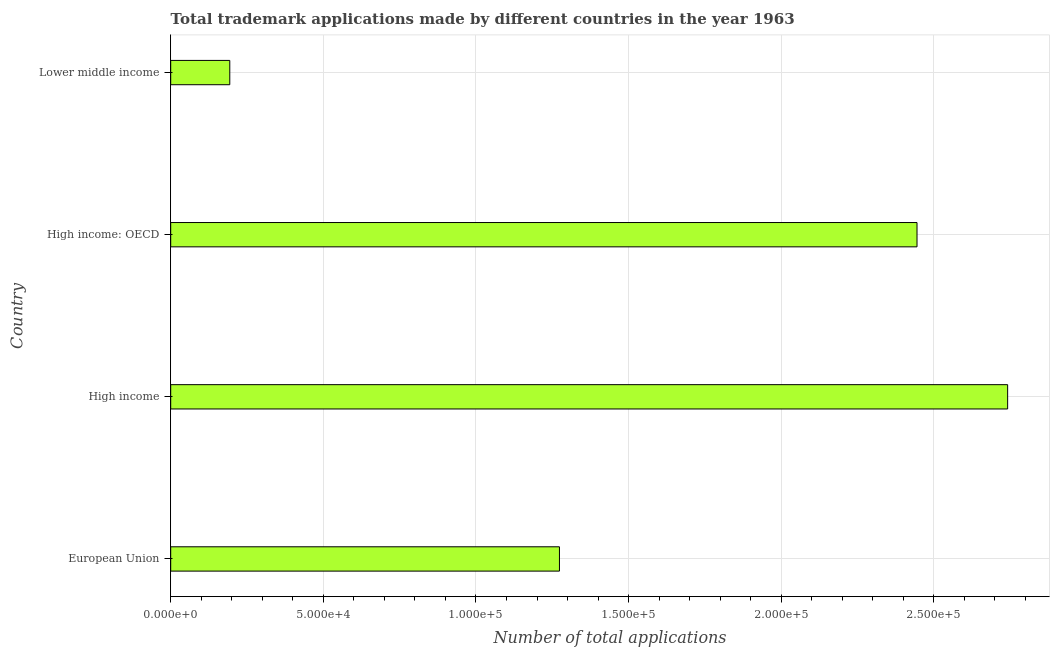Does the graph contain any zero values?
Keep it short and to the point. No. What is the title of the graph?
Provide a short and direct response. Total trademark applications made by different countries in the year 1963. What is the label or title of the X-axis?
Make the answer very short. Number of total applications. What is the label or title of the Y-axis?
Make the answer very short. Country. What is the number of trademark applications in Lower middle income?
Provide a succinct answer. 1.94e+04. Across all countries, what is the maximum number of trademark applications?
Offer a very short reply. 2.74e+05. Across all countries, what is the minimum number of trademark applications?
Give a very brief answer. 1.94e+04. In which country was the number of trademark applications minimum?
Ensure brevity in your answer.  Lower middle income. What is the sum of the number of trademark applications?
Offer a terse response. 6.65e+05. What is the difference between the number of trademark applications in High income and Lower middle income?
Your answer should be very brief. 2.55e+05. What is the average number of trademark applications per country?
Offer a terse response. 1.66e+05. What is the median number of trademark applications?
Your answer should be very brief. 1.86e+05. In how many countries, is the number of trademark applications greater than 180000 ?
Provide a short and direct response. 2. What is the ratio of the number of trademark applications in High income to that in High income: OECD?
Keep it short and to the point. 1.12. What is the difference between the highest and the second highest number of trademark applications?
Provide a succinct answer. 2.97e+04. What is the difference between the highest and the lowest number of trademark applications?
Give a very brief answer. 2.55e+05. How many bars are there?
Offer a very short reply. 4. Are the values on the major ticks of X-axis written in scientific E-notation?
Your answer should be compact. Yes. What is the Number of total applications in European Union?
Provide a succinct answer. 1.27e+05. What is the Number of total applications of High income?
Make the answer very short. 2.74e+05. What is the Number of total applications of High income: OECD?
Your answer should be compact. 2.44e+05. What is the Number of total applications in Lower middle income?
Keep it short and to the point. 1.94e+04. What is the difference between the Number of total applications in European Union and High income?
Provide a succinct answer. -1.47e+05. What is the difference between the Number of total applications in European Union and High income: OECD?
Provide a short and direct response. -1.17e+05. What is the difference between the Number of total applications in European Union and Lower middle income?
Your answer should be compact. 1.08e+05. What is the difference between the Number of total applications in High income and High income: OECD?
Give a very brief answer. 2.97e+04. What is the difference between the Number of total applications in High income and Lower middle income?
Offer a terse response. 2.55e+05. What is the difference between the Number of total applications in High income: OECD and Lower middle income?
Offer a very short reply. 2.25e+05. What is the ratio of the Number of total applications in European Union to that in High income?
Offer a terse response. 0.46. What is the ratio of the Number of total applications in European Union to that in High income: OECD?
Provide a short and direct response. 0.52. What is the ratio of the Number of total applications in European Union to that in Lower middle income?
Make the answer very short. 6.58. What is the ratio of the Number of total applications in High income to that in High income: OECD?
Provide a short and direct response. 1.12. What is the ratio of the Number of total applications in High income to that in Lower middle income?
Your answer should be compact. 14.17. What is the ratio of the Number of total applications in High income: OECD to that in Lower middle income?
Ensure brevity in your answer.  12.63. 